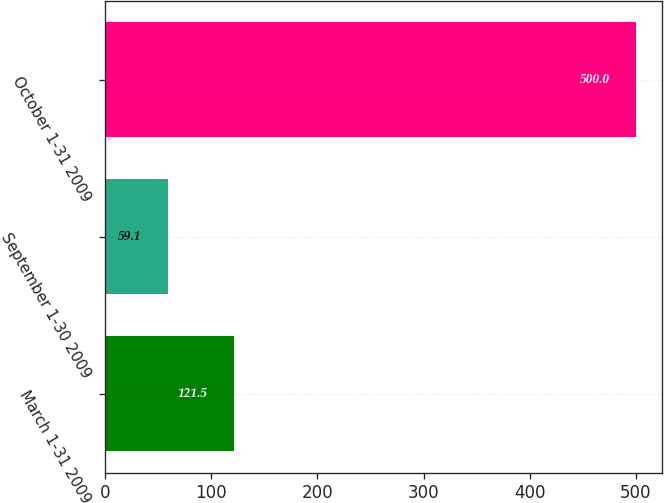Convert chart to OTSL. <chart><loc_0><loc_0><loc_500><loc_500><bar_chart><fcel>March 1-31 2009<fcel>September 1-30 2009<fcel>October 1-31 2009<nl><fcel>121.5<fcel>59.1<fcel>500<nl></chart> 